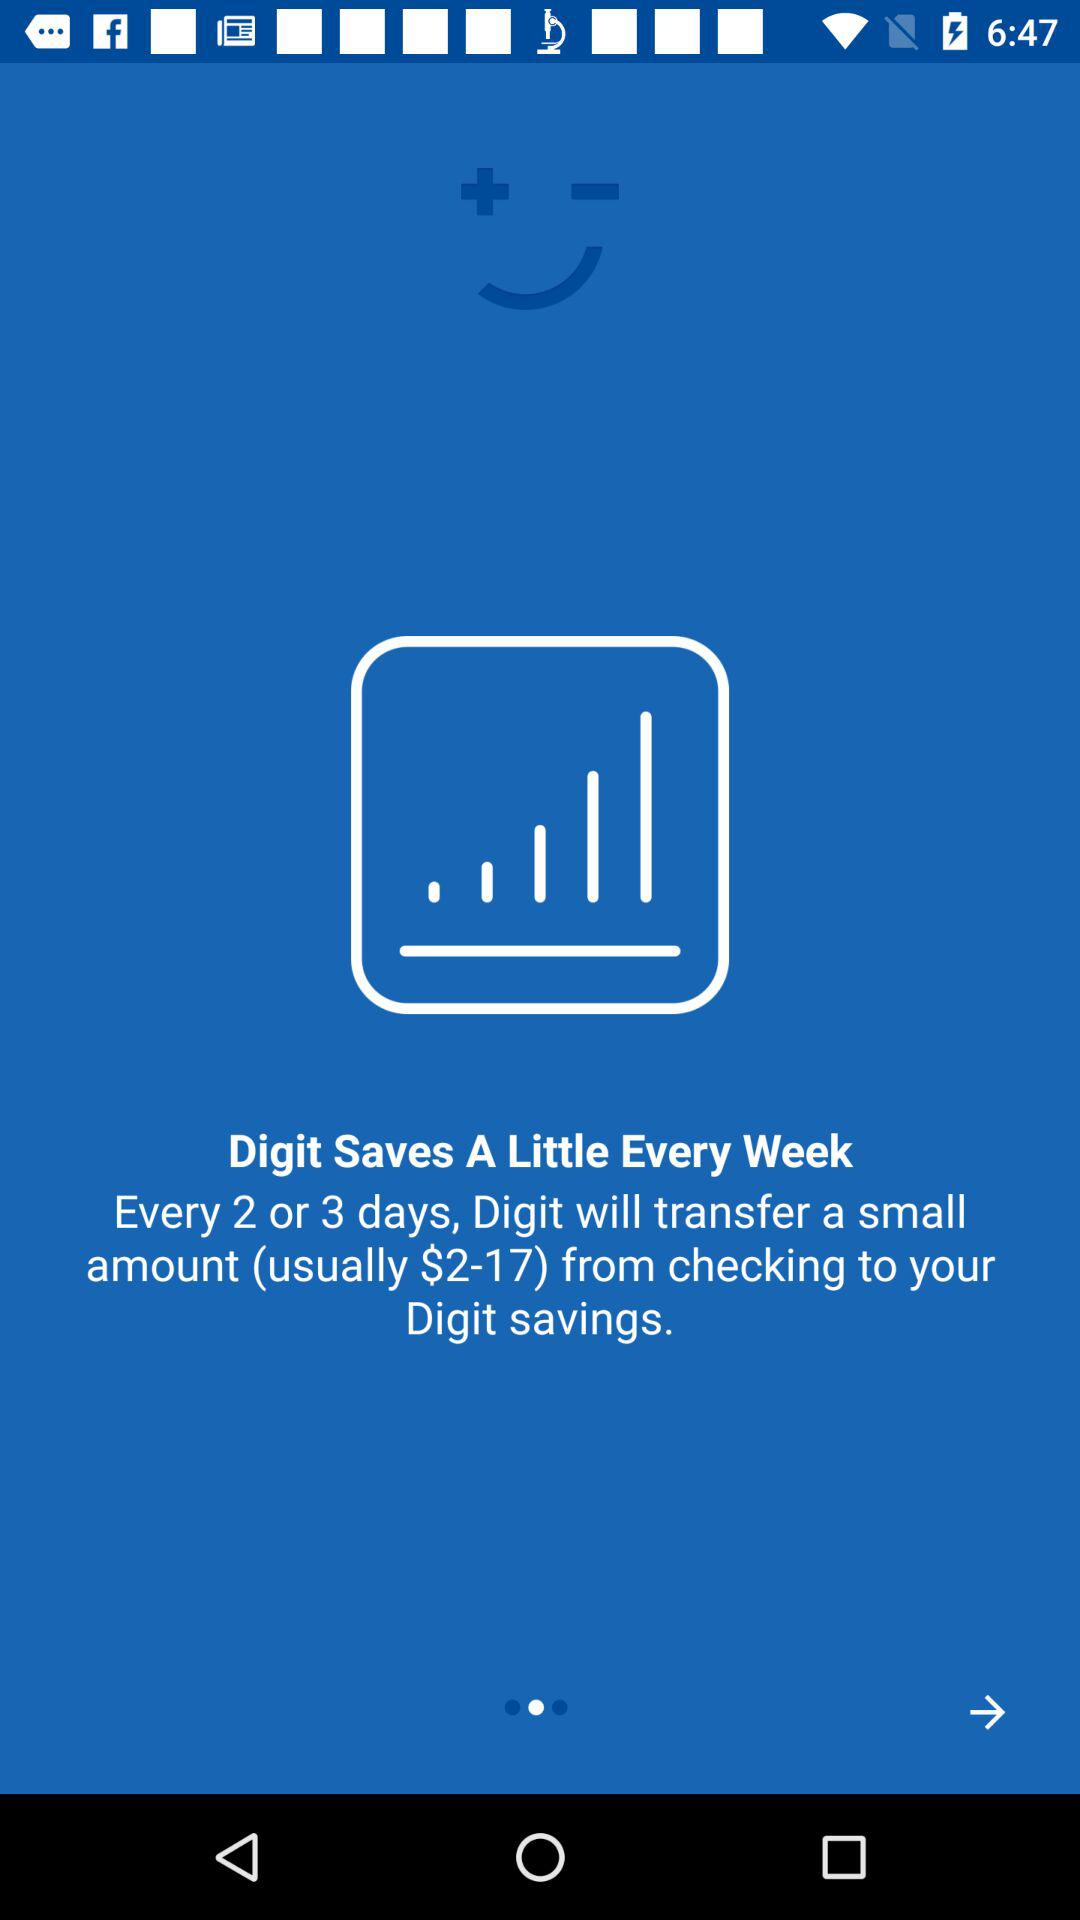In how many days will "Digit" transfer a small amount? "Digit" will transfer a small amount every 2 or 3 days. 